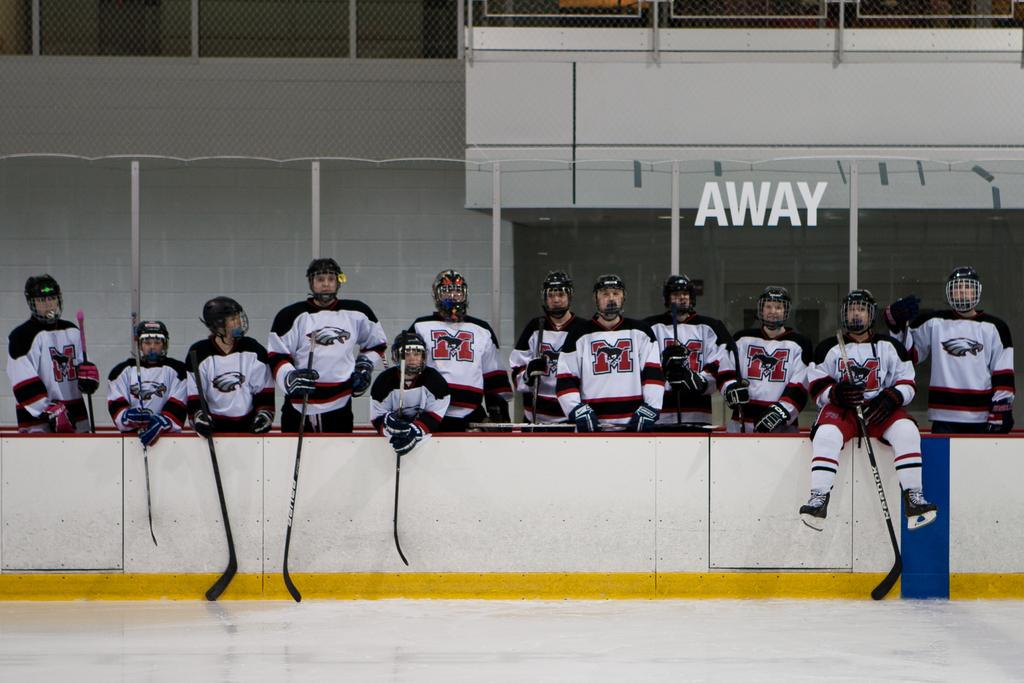<image>
Create a compact narrative representing the image presented. A member of the away team sits on the wall around the ice rink. 